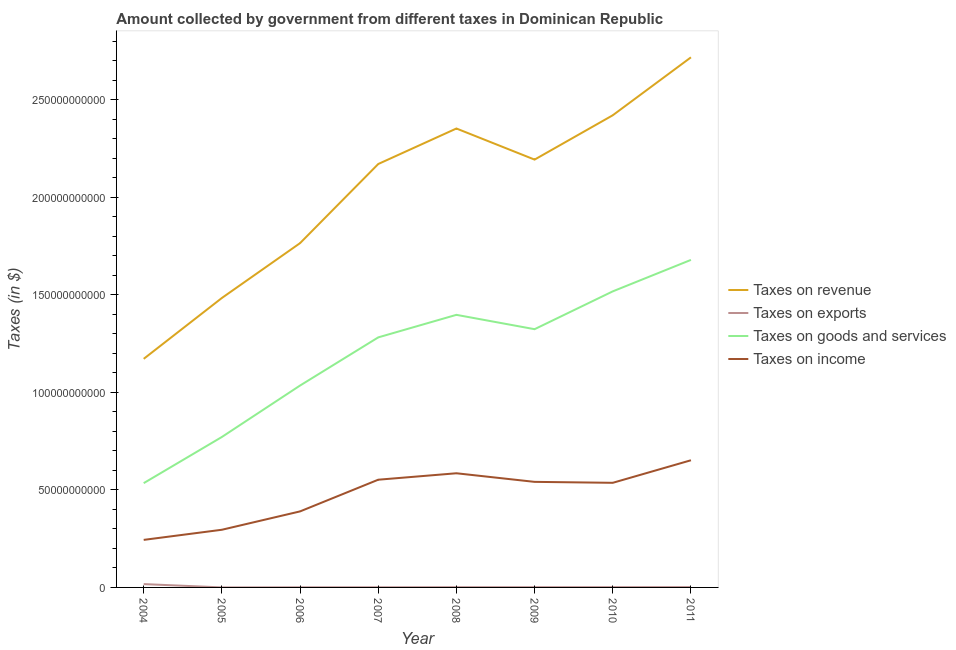How many different coloured lines are there?
Give a very brief answer. 4. Is the number of lines equal to the number of legend labels?
Offer a terse response. Yes. What is the amount collected as tax on exports in 2007?
Offer a very short reply. 8.25e+07. Across all years, what is the maximum amount collected as tax on income?
Make the answer very short. 6.52e+1. Across all years, what is the minimum amount collected as tax on revenue?
Ensure brevity in your answer.  1.17e+11. What is the total amount collected as tax on revenue in the graph?
Provide a succinct answer. 1.63e+12. What is the difference between the amount collected as tax on goods in 2007 and that in 2008?
Give a very brief answer. -1.16e+1. What is the difference between the amount collected as tax on income in 2011 and the amount collected as tax on exports in 2008?
Offer a very short reply. 6.51e+1. What is the average amount collected as tax on income per year?
Offer a very short reply. 4.75e+1. In the year 2004, what is the difference between the amount collected as tax on exports and amount collected as tax on revenue?
Provide a succinct answer. -1.15e+11. What is the ratio of the amount collected as tax on exports in 2005 to that in 2009?
Give a very brief answer. 0.1. Is the difference between the amount collected as tax on exports in 2004 and 2010 greater than the difference between the amount collected as tax on revenue in 2004 and 2010?
Offer a very short reply. Yes. What is the difference between the highest and the second highest amount collected as tax on exports?
Provide a succinct answer. 1.52e+09. What is the difference between the highest and the lowest amount collected as tax on goods?
Provide a succinct answer. 1.14e+11. Is it the case that in every year, the sum of the amount collected as tax on revenue and amount collected as tax on exports is greater than the amount collected as tax on goods?
Offer a terse response. Yes. Does the amount collected as tax on income monotonically increase over the years?
Keep it short and to the point. No. Is the amount collected as tax on income strictly greater than the amount collected as tax on goods over the years?
Your answer should be compact. No. What is the difference between two consecutive major ticks on the Y-axis?
Offer a very short reply. 5.00e+1. Are the values on the major ticks of Y-axis written in scientific E-notation?
Make the answer very short. No. How many legend labels are there?
Give a very brief answer. 4. What is the title of the graph?
Make the answer very short. Amount collected by government from different taxes in Dominican Republic. What is the label or title of the X-axis?
Provide a short and direct response. Year. What is the label or title of the Y-axis?
Offer a terse response. Taxes (in $). What is the Taxes (in $) of Taxes on revenue in 2004?
Give a very brief answer. 1.17e+11. What is the Taxes (in $) of Taxes on exports in 2004?
Give a very brief answer. 1.71e+09. What is the Taxes (in $) in Taxes on goods and services in 2004?
Provide a succinct answer. 5.35e+1. What is the Taxes (in $) of Taxes on income in 2004?
Offer a terse response. 2.44e+1. What is the Taxes (in $) of Taxes on revenue in 2005?
Offer a very short reply. 1.48e+11. What is the Taxes (in $) in Taxes on exports in 2005?
Make the answer very short. 1.36e+07. What is the Taxes (in $) of Taxes on goods and services in 2005?
Ensure brevity in your answer.  7.71e+1. What is the Taxes (in $) of Taxes on income in 2005?
Keep it short and to the point. 2.96e+1. What is the Taxes (in $) in Taxes on revenue in 2006?
Your answer should be very brief. 1.77e+11. What is the Taxes (in $) of Taxes on exports in 2006?
Offer a very short reply. 6.90e+07. What is the Taxes (in $) of Taxes on goods and services in 2006?
Keep it short and to the point. 1.04e+11. What is the Taxes (in $) in Taxes on income in 2006?
Offer a terse response. 3.90e+1. What is the Taxes (in $) in Taxes on revenue in 2007?
Ensure brevity in your answer.  2.17e+11. What is the Taxes (in $) in Taxes on exports in 2007?
Provide a succinct answer. 8.25e+07. What is the Taxes (in $) in Taxes on goods and services in 2007?
Offer a very short reply. 1.28e+11. What is the Taxes (in $) of Taxes on income in 2007?
Your answer should be very brief. 5.52e+1. What is the Taxes (in $) of Taxes on revenue in 2008?
Ensure brevity in your answer.  2.35e+11. What is the Taxes (in $) of Taxes on exports in 2008?
Provide a short and direct response. 1.28e+08. What is the Taxes (in $) of Taxes on goods and services in 2008?
Ensure brevity in your answer.  1.40e+11. What is the Taxes (in $) of Taxes on income in 2008?
Keep it short and to the point. 5.85e+1. What is the Taxes (in $) of Taxes on revenue in 2009?
Offer a terse response. 2.19e+11. What is the Taxes (in $) of Taxes on exports in 2009?
Your answer should be compact. 1.32e+08. What is the Taxes (in $) in Taxes on goods and services in 2009?
Your answer should be very brief. 1.32e+11. What is the Taxes (in $) in Taxes on income in 2009?
Make the answer very short. 5.41e+1. What is the Taxes (in $) in Taxes on revenue in 2010?
Keep it short and to the point. 2.42e+11. What is the Taxes (in $) in Taxes on exports in 2010?
Ensure brevity in your answer.  1.46e+08. What is the Taxes (in $) of Taxes on goods and services in 2010?
Your response must be concise. 1.52e+11. What is the Taxes (in $) of Taxes on income in 2010?
Your answer should be very brief. 5.36e+1. What is the Taxes (in $) of Taxes on revenue in 2011?
Keep it short and to the point. 2.72e+11. What is the Taxes (in $) in Taxes on exports in 2011?
Ensure brevity in your answer.  1.81e+08. What is the Taxes (in $) in Taxes on goods and services in 2011?
Ensure brevity in your answer.  1.68e+11. What is the Taxes (in $) of Taxes on income in 2011?
Provide a succinct answer. 6.52e+1. Across all years, what is the maximum Taxes (in $) of Taxes on revenue?
Your answer should be very brief. 2.72e+11. Across all years, what is the maximum Taxes (in $) in Taxes on exports?
Provide a succinct answer. 1.71e+09. Across all years, what is the maximum Taxes (in $) of Taxes on goods and services?
Keep it short and to the point. 1.68e+11. Across all years, what is the maximum Taxes (in $) in Taxes on income?
Provide a short and direct response. 6.52e+1. Across all years, what is the minimum Taxes (in $) of Taxes on revenue?
Provide a short and direct response. 1.17e+11. Across all years, what is the minimum Taxes (in $) of Taxes on exports?
Your answer should be compact. 1.36e+07. Across all years, what is the minimum Taxes (in $) of Taxes on goods and services?
Your answer should be compact. 5.35e+1. Across all years, what is the minimum Taxes (in $) of Taxes on income?
Your answer should be compact. 2.44e+1. What is the total Taxes (in $) of Taxes on revenue in the graph?
Provide a short and direct response. 1.63e+12. What is the total Taxes (in $) in Taxes on exports in the graph?
Give a very brief answer. 2.46e+09. What is the total Taxes (in $) of Taxes on goods and services in the graph?
Provide a succinct answer. 9.54e+11. What is the total Taxes (in $) in Taxes on income in the graph?
Make the answer very short. 3.80e+11. What is the difference between the Taxes (in $) of Taxes on revenue in 2004 and that in 2005?
Keep it short and to the point. -3.12e+1. What is the difference between the Taxes (in $) of Taxes on exports in 2004 and that in 2005?
Offer a very short reply. 1.69e+09. What is the difference between the Taxes (in $) in Taxes on goods and services in 2004 and that in 2005?
Your answer should be compact. -2.37e+1. What is the difference between the Taxes (in $) of Taxes on income in 2004 and that in 2005?
Provide a succinct answer. -5.20e+09. What is the difference between the Taxes (in $) of Taxes on revenue in 2004 and that in 2006?
Your answer should be very brief. -5.93e+1. What is the difference between the Taxes (in $) of Taxes on exports in 2004 and that in 2006?
Your answer should be compact. 1.64e+09. What is the difference between the Taxes (in $) in Taxes on goods and services in 2004 and that in 2006?
Offer a very short reply. -5.01e+1. What is the difference between the Taxes (in $) in Taxes on income in 2004 and that in 2006?
Ensure brevity in your answer.  -1.46e+1. What is the difference between the Taxes (in $) of Taxes on revenue in 2004 and that in 2007?
Offer a very short reply. -9.99e+1. What is the difference between the Taxes (in $) in Taxes on exports in 2004 and that in 2007?
Provide a succinct answer. 1.62e+09. What is the difference between the Taxes (in $) in Taxes on goods and services in 2004 and that in 2007?
Your answer should be compact. -7.47e+1. What is the difference between the Taxes (in $) of Taxes on income in 2004 and that in 2007?
Keep it short and to the point. -3.09e+1. What is the difference between the Taxes (in $) of Taxes on revenue in 2004 and that in 2008?
Your response must be concise. -1.18e+11. What is the difference between the Taxes (in $) in Taxes on exports in 2004 and that in 2008?
Provide a short and direct response. 1.58e+09. What is the difference between the Taxes (in $) of Taxes on goods and services in 2004 and that in 2008?
Your response must be concise. -8.63e+1. What is the difference between the Taxes (in $) of Taxes on income in 2004 and that in 2008?
Your answer should be very brief. -3.42e+1. What is the difference between the Taxes (in $) of Taxes on revenue in 2004 and that in 2009?
Offer a terse response. -1.02e+11. What is the difference between the Taxes (in $) of Taxes on exports in 2004 and that in 2009?
Keep it short and to the point. 1.57e+09. What is the difference between the Taxes (in $) in Taxes on goods and services in 2004 and that in 2009?
Offer a very short reply. -7.89e+1. What is the difference between the Taxes (in $) in Taxes on income in 2004 and that in 2009?
Give a very brief answer. -2.98e+1. What is the difference between the Taxes (in $) in Taxes on revenue in 2004 and that in 2010?
Make the answer very short. -1.25e+11. What is the difference between the Taxes (in $) in Taxes on exports in 2004 and that in 2010?
Keep it short and to the point. 1.56e+09. What is the difference between the Taxes (in $) of Taxes on goods and services in 2004 and that in 2010?
Provide a succinct answer. -9.83e+1. What is the difference between the Taxes (in $) in Taxes on income in 2004 and that in 2010?
Your response must be concise. -2.93e+1. What is the difference between the Taxes (in $) in Taxes on revenue in 2004 and that in 2011?
Your response must be concise. -1.55e+11. What is the difference between the Taxes (in $) in Taxes on exports in 2004 and that in 2011?
Your response must be concise. 1.52e+09. What is the difference between the Taxes (in $) in Taxes on goods and services in 2004 and that in 2011?
Offer a very short reply. -1.14e+11. What is the difference between the Taxes (in $) in Taxes on income in 2004 and that in 2011?
Provide a succinct answer. -4.08e+1. What is the difference between the Taxes (in $) of Taxes on revenue in 2005 and that in 2006?
Make the answer very short. -2.81e+1. What is the difference between the Taxes (in $) of Taxes on exports in 2005 and that in 2006?
Offer a very short reply. -5.54e+07. What is the difference between the Taxes (in $) of Taxes on goods and services in 2005 and that in 2006?
Provide a short and direct response. -2.64e+1. What is the difference between the Taxes (in $) in Taxes on income in 2005 and that in 2006?
Offer a terse response. -9.41e+09. What is the difference between the Taxes (in $) of Taxes on revenue in 2005 and that in 2007?
Your answer should be compact. -6.87e+1. What is the difference between the Taxes (in $) in Taxes on exports in 2005 and that in 2007?
Your answer should be compact. -6.89e+07. What is the difference between the Taxes (in $) in Taxes on goods and services in 2005 and that in 2007?
Offer a very short reply. -5.11e+1. What is the difference between the Taxes (in $) of Taxes on income in 2005 and that in 2007?
Keep it short and to the point. -2.57e+1. What is the difference between the Taxes (in $) of Taxes on revenue in 2005 and that in 2008?
Keep it short and to the point. -8.69e+1. What is the difference between the Taxes (in $) of Taxes on exports in 2005 and that in 2008?
Provide a succinct answer. -1.15e+08. What is the difference between the Taxes (in $) in Taxes on goods and services in 2005 and that in 2008?
Your answer should be compact. -6.26e+1. What is the difference between the Taxes (in $) in Taxes on income in 2005 and that in 2008?
Your answer should be compact. -2.90e+1. What is the difference between the Taxes (in $) of Taxes on revenue in 2005 and that in 2009?
Your response must be concise. -7.10e+1. What is the difference between the Taxes (in $) of Taxes on exports in 2005 and that in 2009?
Offer a very short reply. -1.18e+08. What is the difference between the Taxes (in $) in Taxes on goods and services in 2005 and that in 2009?
Provide a short and direct response. -5.53e+1. What is the difference between the Taxes (in $) in Taxes on income in 2005 and that in 2009?
Your answer should be compact. -2.46e+1. What is the difference between the Taxes (in $) in Taxes on revenue in 2005 and that in 2010?
Keep it short and to the point. -9.37e+1. What is the difference between the Taxes (in $) in Taxes on exports in 2005 and that in 2010?
Your answer should be very brief. -1.33e+08. What is the difference between the Taxes (in $) of Taxes on goods and services in 2005 and that in 2010?
Ensure brevity in your answer.  -7.47e+1. What is the difference between the Taxes (in $) of Taxes on income in 2005 and that in 2010?
Your response must be concise. -2.41e+1. What is the difference between the Taxes (in $) of Taxes on revenue in 2005 and that in 2011?
Your response must be concise. -1.23e+11. What is the difference between the Taxes (in $) of Taxes on exports in 2005 and that in 2011?
Provide a short and direct response. -1.68e+08. What is the difference between the Taxes (in $) in Taxes on goods and services in 2005 and that in 2011?
Ensure brevity in your answer.  -9.08e+1. What is the difference between the Taxes (in $) of Taxes on income in 2005 and that in 2011?
Provide a succinct answer. -3.56e+1. What is the difference between the Taxes (in $) of Taxes on revenue in 2006 and that in 2007?
Provide a succinct answer. -4.06e+1. What is the difference between the Taxes (in $) of Taxes on exports in 2006 and that in 2007?
Offer a very short reply. -1.35e+07. What is the difference between the Taxes (in $) of Taxes on goods and services in 2006 and that in 2007?
Give a very brief answer. -2.47e+1. What is the difference between the Taxes (in $) of Taxes on income in 2006 and that in 2007?
Give a very brief answer. -1.63e+1. What is the difference between the Taxes (in $) in Taxes on revenue in 2006 and that in 2008?
Offer a very short reply. -5.88e+1. What is the difference between the Taxes (in $) of Taxes on exports in 2006 and that in 2008?
Your response must be concise. -5.92e+07. What is the difference between the Taxes (in $) of Taxes on goods and services in 2006 and that in 2008?
Give a very brief answer. -3.62e+1. What is the difference between the Taxes (in $) in Taxes on income in 2006 and that in 2008?
Your answer should be very brief. -1.96e+1. What is the difference between the Taxes (in $) of Taxes on revenue in 2006 and that in 2009?
Offer a terse response. -4.28e+1. What is the difference between the Taxes (in $) of Taxes on exports in 2006 and that in 2009?
Give a very brief answer. -6.27e+07. What is the difference between the Taxes (in $) of Taxes on goods and services in 2006 and that in 2009?
Provide a short and direct response. -2.89e+1. What is the difference between the Taxes (in $) of Taxes on income in 2006 and that in 2009?
Ensure brevity in your answer.  -1.51e+1. What is the difference between the Taxes (in $) in Taxes on revenue in 2006 and that in 2010?
Give a very brief answer. -6.56e+1. What is the difference between the Taxes (in $) of Taxes on exports in 2006 and that in 2010?
Your answer should be compact. -7.73e+07. What is the difference between the Taxes (in $) in Taxes on goods and services in 2006 and that in 2010?
Give a very brief answer. -4.83e+1. What is the difference between the Taxes (in $) of Taxes on income in 2006 and that in 2010?
Provide a succinct answer. -1.47e+1. What is the difference between the Taxes (in $) of Taxes on revenue in 2006 and that in 2011?
Offer a terse response. -9.53e+1. What is the difference between the Taxes (in $) in Taxes on exports in 2006 and that in 2011?
Make the answer very short. -1.12e+08. What is the difference between the Taxes (in $) of Taxes on goods and services in 2006 and that in 2011?
Keep it short and to the point. -6.44e+1. What is the difference between the Taxes (in $) in Taxes on income in 2006 and that in 2011?
Your answer should be compact. -2.62e+1. What is the difference between the Taxes (in $) of Taxes on revenue in 2007 and that in 2008?
Your response must be concise. -1.82e+1. What is the difference between the Taxes (in $) of Taxes on exports in 2007 and that in 2008?
Your answer should be compact. -4.56e+07. What is the difference between the Taxes (in $) in Taxes on goods and services in 2007 and that in 2008?
Make the answer very short. -1.16e+1. What is the difference between the Taxes (in $) in Taxes on income in 2007 and that in 2008?
Your response must be concise. -3.30e+09. What is the difference between the Taxes (in $) of Taxes on revenue in 2007 and that in 2009?
Your response must be concise. -2.26e+09. What is the difference between the Taxes (in $) of Taxes on exports in 2007 and that in 2009?
Provide a short and direct response. -4.92e+07. What is the difference between the Taxes (in $) of Taxes on goods and services in 2007 and that in 2009?
Provide a short and direct response. -4.20e+09. What is the difference between the Taxes (in $) in Taxes on income in 2007 and that in 2009?
Provide a short and direct response. 1.10e+09. What is the difference between the Taxes (in $) of Taxes on revenue in 2007 and that in 2010?
Your answer should be very brief. -2.50e+1. What is the difference between the Taxes (in $) of Taxes on exports in 2007 and that in 2010?
Your response must be concise. -6.38e+07. What is the difference between the Taxes (in $) of Taxes on goods and services in 2007 and that in 2010?
Offer a terse response. -2.36e+1. What is the difference between the Taxes (in $) of Taxes on income in 2007 and that in 2010?
Give a very brief answer. 1.59e+09. What is the difference between the Taxes (in $) of Taxes on revenue in 2007 and that in 2011?
Make the answer very short. -5.47e+1. What is the difference between the Taxes (in $) in Taxes on exports in 2007 and that in 2011?
Your answer should be very brief. -9.87e+07. What is the difference between the Taxes (in $) of Taxes on goods and services in 2007 and that in 2011?
Provide a succinct answer. -3.97e+1. What is the difference between the Taxes (in $) in Taxes on income in 2007 and that in 2011?
Keep it short and to the point. -9.97e+09. What is the difference between the Taxes (in $) in Taxes on revenue in 2008 and that in 2009?
Make the answer very short. 1.59e+1. What is the difference between the Taxes (in $) of Taxes on exports in 2008 and that in 2009?
Ensure brevity in your answer.  -3.52e+06. What is the difference between the Taxes (in $) of Taxes on goods and services in 2008 and that in 2009?
Keep it short and to the point. 7.36e+09. What is the difference between the Taxes (in $) in Taxes on income in 2008 and that in 2009?
Offer a very short reply. 4.41e+09. What is the difference between the Taxes (in $) of Taxes on revenue in 2008 and that in 2010?
Your answer should be very brief. -6.79e+09. What is the difference between the Taxes (in $) in Taxes on exports in 2008 and that in 2010?
Offer a terse response. -1.82e+07. What is the difference between the Taxes (in $) of Taxes on goods and services in 2008 and that in 2010?
Your response must be concise. -1.20e+1. What is the difference between the Taxes (in $) of Taxes on income in 2008 and that in 2010?
Your response must be concise. 4.89e+09. What is the difference between the Taxes (in $) of Taxes on revenue in 2008 and that in 2011?
Your answer should be very brief. -3.65e+1. What is the difference between the Taxes (in $) in Taxes on exports in 2008 and that in 2011?
Make the answer very short. -5.31e+07. What is the difference between the Taxes (in $) of Taxes on goods and services in 2008 and that in 2011?
Offer a very short reply. -2.82e+1. What is the difference between the Taxes (in $) in Taxes on income in 2008 and that in 2011?
Provide a succinct answer. -6.67e+09. What is the difference between the Taxes (in $) in Taxes on revenue in 2009 and that in 2010?
Your response must be concise. -2.27e+1. What is the difference between the Taxes (in $) in Taxes on exports in 2009 and that in 2010?
Keep it short and to the point. -1.46e+07. What is the difference between the Taxes (in $) of Taxes on goods and services in 2009 and that in 2010?
Give a very brief answer. -1.94e+1. What is the difference between the Taxes (in $) of Taxes on income in 2009 and that in 2010?
Keep it short and to the point. 4.84e+08. What is the difference between the Taxes (in $) of Taxes on revenue in 2009 and that in 2011?
Your answer should be very brief. -5.24e+1. What is the difference between the Taxes (in $) in Taxes on exports in 2009 and that in 2011?
Give a very brief answer. -4.95e+07. What is the difference between the Taxes (in $) of Taxes on goods and services in 2009 and that in 2011?
Your response must be concise. -3.55e+1. What is the difference between the Taxes (in $) in Taxes on income in 2009 and that in 2011?
Give a very brief answer. -1.11e+1. What is the difference between the Taxes (in $) of Taxes on revenue in 2010 and that in 2011?
Keep it short and to the point. -2.97e+1. What is the difference between the Taxes (in $) in Taxes on exports in 2010 and that in 2011?
Keep it short and to the point. -3.49e+07. What is the difference between the Taxes (in $) of Taxes on goods and services in 2010 and that in 2011?
Your answer should be very brief. -1.61e+1. What is the difference between the Taxes (in $) of Taxes on income in 2010 and that in 2011?
Make the answer very short. -1.16e+1. What is the difference between the Taxes (in $) of Taxes on revenue in 2004 and the Taxes (in $) of Taxes on exports in 2005?
Your answer should be very brief. 1.17e+11. What is the difference between the Taxes (in $) of Taxes on revenue in 2004 and the Taxes (in $) of Taxes on goods and services in 2005?
Keep it short and to the point. 4.01e+1. What is the difference between the Taxes (in $) in Taxes on revenue in 2004 and the Taxes (in $) in Taxes on income in 2005?
Keep it short and to the point. 8.76e+1. What is the difference between the Taxes (in $) of Taxes on exports in 2004 and the Taxes (in $) of Taxes on goods and services in 2005?
Your answer should be very brief. -7.54e+1. What is the difference between the Taxes (in $) of Taxes on exports in 2004 and the Taxes (in $) of Taxes on income in 2005?
Your answer should be very brief. -2.79e+1. What is the difference between the Taxes (in $) of Taxes on goods and services in 2004 and the Taxes (in $) of Taxes on income in 2005?
Your response must be concise. 2.39e+1. What is the difference between the Taxes (in $) in Taxes on revenue in 2004 and the Taxes (in $) in Taxes on exports in 2006?
Your answer should be compact. 1.17e+11. What is the difference between the Taxes (in $) in Taxes on revenue in 2004 and the Taxes (in $) in Taxes on goods and services in 2006?
Your response must be concise. 1.37e+1. What is the difference between the Taxes (in $) of Taxes on revenue in 2004 and the Taxes (in $) of Taxes on income in 2006?
Provide a succinct answer. 7.82e+1. What is the difference between the Taxes (in $) in Taxes on exports in 2004 and the Taxes (in $) in Taxes on goods and services in 2006?
Provide a short and direct response. -1.02e+11. What is the difference between the Taxes (in $) in Taxes on exports in 2004 and the Taxes (in $) in Taxes on income in 2006?
Your response must be concise. -3.73e+1. What is the difference between the Taxes (in $) of Taxes on goods and services in 2004 and the Taxes (in $) of Taxes on income in 2006?
Keep it short and to the point. 1.45e+1. What is the difference between the Taxes (in $) of Taxes on revenue in 2004 and the Taxes (in $) of Taxes on exports in 2007?
Your answer should be compact. 1.17e+11. What is the difference between the Taxes (in $) in Taxes on revenue in 2004 and the Taxes (in $) in Taxes on goods and services in 2007?
Ensure brevity in your answer.  -1.10e+1. What is the difference between the Taxes (in $) of Taxes on revenue in 2004 and the Taxes (in $) of Taxes on income in 2007?
Keep it short and to the point. 6.20e+1. What is the difference between the Taxes (in $) of Taxes on exports in 2004 and the Taxes (in $) of Taxes on goods and services in 2007?
Your response must be concise. -1.27e+11. What is the difference between the Taxes (in $) of Taxes on exports in 2004 and the Taxes (in $) of Taxes on income in 2007?
Make the answer very short. -5.35e+1. What is the difference between the Taxes (in $) in Taxes on goods and services in 2004 and the Taxes (in $) in Taxes on income in 2007?
Offer a very short reply. -1.76e+09. What is the difference between the Taxes (in $) in Taxes on revenue in 2004 and the Taxes (in $) in Taxes on exports in 2008?
Provide a short and direct response. 1.17e+11. What is the difference between the Taxes (in $) in Taxes on revenue in 2004 and the Taxes (in $) in Taxes on goods and services in 2008?
Ensure brevity in your answer.  -2.26e+1. What is the difference between the Taxes (in $) of Taxes on revenue in 2004 and the Taxes (in $) of Taxes on income in 2008?
Keep it short and to the point. 5.87e+1. What is the difference between the Taxes (in $) in Taxes on exports in 2004 and the Taxes (in $) in Taxes on goods and services in 2008?
Your answer should be very brief. -1.38e+11. What is the difference between the Taxes (in $) of Taxes on exports in 2004 and the Taxes (in $) of Taxes on income in 2008?
Your response must be concise. -5.68e+1. What is the difference between the Taxes (in $) in Taxes on goods and services in 2004 and the Taxes (in $) in Taxes on income in 2008?
Provide a succinct answer. -5.07e+09. What is the difference between the Taxes (in $) of Taxes on revenue in 2004 and the Taxes (in $) of Taxes on exports in 2009?
Keep it short and to the point. 1.17e+11. What is the difference between the Taxes (in $) of Taxes on revenue in 2004 and the Taxes (in $) of Taxes on goods and services in 2009?
Offer a very short reply. -1.52e+1. What is the difference between the Taxes (in $) in Taxes on revenue in 2004 and the Taxes (in $) in Taxes on income in 2009?
Ensure brevity in your answer.  6.31e+1. What is the difference between the Taxes (in $) in Taxes on exports in 2004 and the Taxes (in $) in Taxes on goods and services in 2009?
Provide a succinct answer. -1.31e+11. What is the difference between the Taxes (in $) in Taxes on exports in 2004 and the Taxes (in $) in Taxes on income in 2009?
Your answer should be compact. -5.24e+1. What is the difference between the Taxes (in $) in Taxes on goods and services in 2004 and the Taxes (in $) in Taxes on income in 2009?
Offer a terse response. -6.59e+08. What is the difference between the Taxes (in $) in Taxes on revenue in 2004 and the Taxes (in $) in Taxes on exports in 2010?
Provide a succinct answer. 1.17e+11. What is the difference between the Taxes (in $) in Taxes on revenue in 2004 and the Taxes (in $) in Taxes on goods and services in 2010?
Make the answer very short. -3.46e+1. What is the difference between the Taxes (in $) in Taxes on revenue in 2004 and the Taxes (in $) in Taxes on income in 2010?
Give a very brief answer. 6.36e+1. What is the difference between the Taxes (in $) in Taxes on exports in 2004 and the Taxes (in $) in Taxes on goods and services in 2010?
Make the answer very short. -1.50e+11. What is the difference between the Taxes (in $) of Taxes on exports in 2004 and the Taxes (in $) of Taxes on income in 2010?
Provide a succinct answer. -5.19e+1. What is the difference between the Taxes (in $) in Taxes on goods and services in 2004 and the Taxes (in $) in Taxes on income in 2010?
Ensure brevity in your answer.  -1.75e+08. What is the difference between the Taxes (in $) in Taxes on revenue in 2004 and the Taxes (in $) in Taxes on exports in 2011?
Offer a terse response. 1.17e+11. What is the difference between the Taxes (in $) of Taxes on revenue in 2004 and the Taxes (in $) of Taxes on goods and services in 2011?
Keep it short and to the point. -5.07e+1. What is the difference between the Taxes (in $) in Taxes on revenue in 2004 and the Taxes (in $) in Taxes on income in 2011?
Make the answer very short. 5.20e+1. What is the difference between the Taxes (in $) in Taxes on exports in 2004 and the Taxes (in $) in Taxes on goods and services in 2011?
Provide a short and direct response. -1.66e+11. What is the difference between the Taxes (in $) of Taxes on exports in 2004 and the Taxes (in $) of Taxes on income in 2011?
Keep it short and to the point. -6.35e+1. What is the difference between the Taxes (in $) in Taxes on goods and services in 2004 and the Taxes (in $) in Taxes on income in 2011?
Offer a very short reply. -1.17e+1. What is the difference between the Taxes (in $) of Taxes on revenue in 2005 and the Taxes (in $) of Taxes on exports in 2006?
Give a very brief answer. 1.48e+11. What is the difference between the Taxes (in $) of Taxes on revenue in 2005 and the Taxes (in $) of Taxes on goods and services in 2006?
Offer a very short reply. 4.49e+1. What is the difference between the Taxes (in $) in Taxes on revenue in 2005 and the Taxes (in $) in Taxes on income in 2006?
Provide a succinct answer. 1.09e+11. What is the difference between the Taxes (in $) in Taxes on exports in 2005 and the Taxes (in $) in Taxes on goods and services in 2006?
Keep it short and to the point. -1.04e+11. What is the difference between the Taxes (in $) of Taxes on exports in 2005 and the Taxes (in $) of Taxes on income in 2006?
Your answer should be compact. -3.90e+1. What is the difference between the Taxes (in $) of Taxes on goods and services in 2005 and the Taxes (in $) of Taxes on income in 2006?
Your answer should be very brief. 3.82e+1. What is the difference between the Taxes (in $) in Taxes on revenue in 2005 and the Taxes (in $) in Taxes on exports in 2007?
Offer a terse response. 1.48e+11. What is the difference between the Taxes (in $) in Taxes on revenue in 2005 and the Taxes (in $) in Taxes on goods and services in 2007?
Keep it short and to the point. 2.02e+1. What is the difference between the Taxes (in $) of Taxes on revenue in 2005 and the Taxes (in $) of Taxes on income in 2007?
Make the answer very short. 9.32e+1. What is the difference between the Taxes (in $) in Taxes on exports in 2005 and the Taxes (in $) in Taxes on goods and services in 2007?
Make the answer very short. -1.28e+11. What is the difference between the Taxes (in $) of Taxes on exports in 2005 and the Taxes (in $) of Taxes on income in 2007?
Make the answer very short. -5.52e+1. What is the difference between the Taxes (in $) of Taxes on goods and services in 2005 and the Taxes (in $) of Taxes on income in 2007?
Offer a terse response. 2.19e+1. What is the difference between the Taxes (in $) in Taxes on revenue in 2005 and the Taxes (in $) in Taxes on exports in 2008?
Give a very brief answer. 1.48e+11. What is the difference between the Taxes (in $) in Taxes on revenue in 2005 and the Taxes (in $) in Taxes on goods and services in 2008?
Offer a terse response. 8.65e+09. What is the difference between the Taxes (in $) of Taxes on revenue in 2005 and the Taxes (in $) of Taxes on income in 2008?
Ensure brevity in your answer.  8.99e+1. What is the difference between the Taxes (in $) in Taxes on exports in 2005 and the Taxes (in $) in Taxes on goods and services in 2008?
Your response must be concise. -1.40e+11. What is the difference between the Taxes (in $) of Taxes on exports in 2005 and the Taxes (in $) of Taxes on income in 2008?
Your answer should be compact. -5.85e+1. What is the difference between the Taxes (in $) of Taxes on goods and services in 2005 and the Taxes (in $) of Taxes on income in 2008?
Make the answer very short. 1.86e+1. What is the difference between the Taxes (in $) of Taxes on revenue in 2005 and the Taxes (in $) of Taxes on exports in 2009?
Your answer should be very brief. 1.48e+11. What is the difference between the Taxes (in $) in Taxes on revenue in 2005 and the Taxes (in $) in Taxes on goods and services in 2009?
Keep it short and to the point. 1.60e+1. What is the difference between the Taxes (in $) of Taxes on revenue in 2005 and the Taxes (in $) of Taxes on income in 2009?
Your answer should be compact. 9.43e+1. What is the difference between the Taxes (in $) in Taxes on exports in 2005 and the Taxes (in $) in Taxes on goods and services in 2009?
Your answer should be very brief. -1.32e+11. What is the difference between the Taxes (in $) in Taxes on exports in 2005 and the Taxes (in $) in Taxes on income in 2009?
Your answer should be compact. -5.41e+1. What is the difference between the Taxes (in $) of Taxes on goods and services in 2005 and the Taxes (in $) of Taxes on income in 2009?
Ensure brevity in your answer.  2.30e+1. What is the difference between the Taxes (in $) of Taxes on revenue in 2005 and the Taxes (in $) of Taxes on exports in 2010?
Make the answer very short. 1.48e+11. What is the difference between the Taxes (in $) of Taxes on revenue in 2005 and the Taxes (in $) of Taxes on goods and services in 2010?
Your answer should be very brief. -3.39e+09. What is the difference between the Taxes (in $) in Taxes on revenue in 2005 and the Taxes (in $) in Taxes on income in 2010?
Your answer should be compact. 9.48e+1. What is the difference between the Taxes (in $) in Taxes on exports in 2005 and the Taxes (in $) in Taxes on goods and services in 2010?
Your answer should be compact. -1.52e+11. What is the difference between the Taxes (in $) in Taxes on exports in 2005 and the Taxes (in $) in Taxes on income in 2010?
Your answer should be compact. -5.36e+1. What is the difference between the Taxes (in $) of Taxes on goods and services in 2005 and the Taxes (in $) of Taxes on income in 2010?
Your answer should be compact. 2.35e+1. What is the difference between the Taxes (in $) of Taxes on revenue in 2005 and the Taxes (in $) of Taxes on exports in 2011?
Make the answer very short. 1.48e+11. What is the difference between the Taxes (in $) of Taxes on revenue in 2005 and the Taxes (in $) of Taxes on goods and services in 2011?
Provide a succinct answer. -1.95e+1. What is the difference between the Taxes (in $) in Taxes on revenue in 2005 and the Taxes (in $) in Taxes on income in 2011?
Make the answer very short. 8.32e+1. What is the difference between the Taxes (in $) in Taxes on exports in 2005 and the Taxes (in $) in Taxes on goods and services in 2011?
Give a very brief answer. -1.68e+11. What is the difference between the Taxes (in $) of Taxes on exports in 2005 and the Taxes (in $) of Taxes on income in 2011?
Offer a very short reply. -6.52e+1. What is the difference between the Taxes (in $) in Taxes on goods and services in 2005 and the Taxes (in $) in Taxes on income in 2011?
Your answer should be very brief. 1.19e+1. What is the difference between the Taxes (in $) in Taxes on revenue in 2006 and the Taxes (in $) in Taxes on exports in 2007?
Make the answer very short. 1.76e+11. What is the difference between the Taxes (in $) in Taxes on revenue in 2006 and the Taxes (in $) in Taxes on goods and services in 2007?
Give a very brief answer. 4.83e+1. What is the difference between the Taxes (in $) in Taxes on revenue in 2006 and the Taxes (in $) in Taxes on income in 2007?
Keep it short and to the point. 1.21e+11. What is the difference between the Taxes (in $) of Taxes on exports in 2006 and the Taxes (in $) of Taxes on goods and services in 2007?
Your response must be concise. -1.28e+11. What is the difference between the Taxes (in $) in Taxes on exports in 2006 and the Taxes (in $) in Taxes on income in 2007?
Provide a short and direct response. -5.52e+1. What is the difference between the Taxes (in $) in Taxes on goods and services in 2006 and the Taxes (in $) in Taxes on income in 2007?
Keep it short and to the point. 4.83e+1. What is the difference between the Taxes (in $) of Taxes on revenue in 2006 and the Taxes (in $) of Taxes on exports in 2008?
Give a very brief answer. 1.76e+11. What is the difference between the Taxes (in $) in Taxes on revenue in 2006 and the Taxes (in $) in Taxes on goods and services in 2008?
Keep it short and to the point. 3.68e+1. What is the difference between the Taxes (in $) in Taxes on revenue in 2006 and the Taxes (in $) in Taxes on income in 2008?
Ensure brevity in your answer.  1.18e+11. What is the difference between the Taxes (in $) of Taxes on exports in 2006 and the Taxes (in $) of Taxes on goods and services in 2008?
Offer a very short reply. -1.40e+11. What is the difference between the Taxes (in $) in Taxes on exports in 2006 and the Taxes (in $) in Taxes on income in 2008?
Give a very brief answer. -5.85e+1. What is the difference between the Taxes (in $) in Taxes on goods and services in 2006 and the Taxes (in $) in Taxes on income in 2008?
Offer a very short reply. 4.50e+1. What is the difference between the Taxes (in $) of Taxes on revenue in 2006 and the Taxes (in $) of Taxes on exports in 2009?
Offer a very short reply. 1.76e+11. What is the difference between the Taxes (in $) of Taxes on revenue in 2006 and the Taxes (in $) of Taxes on goods and services in 2009?
Keep it short and to the point. 4.41e+1. What is the difference between the Taxes (in $) of Taxes on revenue in 2006 and the Taxes (in $) of Taxes on income in 2009?
Provide a succinct answer. 1.22e+11. What is the difference between the Taxes (in $) in Taxes on exports in 2006 and the Taxes (in $) in Taxes on goods and services in 2009?
Provide a short and direct response. -1.32e+11. What is the difference between the Taxes (in $) in Taxes on exports in 2006 and the Taxes (in $) in Taxes on income in 2009?
Your response must be concise. -5.41e+1. What is the difference between the Taxes (in $) of Taxes on goods and services in 2006 and the Taxes (in $) of Taxes on income in 2009?
Give a very brief answer. 4.94e+1. What is the difference between the Taxes (in $) of Taxes on revenue in 2006 and the Taxes (in $) of Taxes on exports in 2010?
Keep it short and to the point. 1.76e+11. What is the difference between the Taxes (in $) in Taxes on revenue in 2006 and the Taxes (in $) in Taxes on goods and services in 2010?
Provide a short and direct response. 2.47e+1. What is the difference between the Taxes (in $) of Taxes on revenue in 2006 and the Taxes (in $) of Taxes on income in 2010?
Give a very brief answer. 1.23e+11. What is the difference between the Taxes (in $) of Taxes on exports in 2006 and the Taxes (in $) of Taxes on goods and services in 2010?
Offer a very short reply. -1.52e+11. What is the difference between the Taxes (in $) in Taxes on exports in 2006 and the Taxes (in $) in Taxes on income in 2010?
Ensure brevity in your answer.  -5.36e+1. What is the difference between the Taxes (in $) of Taxes on goods and services in 2006 and the Taxes (in $) of Taxes on income in 2010?
Offer a very short reply. 4.99e+1. What is the difference between the Taxes (in $) in Taxes on revenue in 2006 and the Taxes (in $) in Taxes on exports in 2011?
Ensure brevity in your answer.  1.76e+11. What is the difference between the Taxes (in $) of Taxes on revenue in 2006 and the Taxes (in $) of Taxes on goods and services in 2011?
Your answer should be compact. 8.59e+09. What is the difference between the Taxes (in $) in Taxes on revenue in 2006 and the Taxes (in $) in Taxes on income in 2011?
Your response must be concise. 1.11e+11. What is the difference between the Taxes (in $) of Taxes on exports in 2006 and the Taxes (in $) of Taxes on goods and services in 2011?
Offer a very short reply. -1.68e+11. What is the difference between the Taxes (in $) of Taxes on exports in 2006 and the Taxes (in $) of Taxes on income in 2011?
Offer a terse response. -6.51e+1. What is the difference between the Taxes (in $) of Taxes on goods and services in 2006 and the Taxes (in $) of Taxes on income in 2011?
Give a very brief answer. 3.83e+1. What is the difference between the Taxes (in $) of Taxes on revenue in 2007 and the Taxes (in $) of Taxes on exports in 2008?
Your response must be concise. 2.17e+11. What is the difference between the Taxes (in $) of Taxes on revenue in 2007 and the Taxes (in $) of Taxes on goods and services in 2008?
Your answer should be very brief. 7.73e+1. What is the difference between the Taxes (in $) of Taxes on revenue in 2007 and the Taxes (in $) of Taxes on income in 2008?
Keep it short and to the point. 1.59e+11. What is the difference between the Taxes (in $) in Taxes on exports in 2007 and the Taxes (in $) in Taxes on goods and services in 2008?
Offer a very short reply. -1.40e+11. What is the difference between the Taxes (in $) of Taxes on exports in 2007 and the Taxes (in $) of Taxes on income in 2008?
Your response must be concise. -5.85e+1. What is the difference between the Taxes (in $) of Taxes on goods and services in 2007 and the Taxes (in $) of Taxes on income in 2008?
Ensure brevity in your answer.  6.97e+1. What is the difference between the Taxes (in $) of Taxes on revenue in 2007 and the Taxes (in $) of Taxes on exports in 2009?
Provide a short and direct response. 2.17e+11. What is the difference between the Taxes (in $) of Taxes on revenue in 2007 and the Taxes (in $) of Taxes on goods and services in 2009?
Offer a terse response. 8.47e+1. What is the difference between the Taxes (in $) of Taxes on revenue in 2007 and the Taxes (in $) of Taxes on income in 2009?
Give a very brief answer. 1.63e+11. What is the difference between the Taxes (in $) in Taxes on exports in 2007 and the Taxes (in $) in Taxes on goods and services in 2009?
Keep it short and to the point. -1.32e+11. What is the difference between the Taxes (in $) of Taxes on exports in 2007 and the Taxes (in $) of Taxes on income in 2009?
Your answer should be very brief. -5.40e+1. What is the difference between the Taxes (in $) in Taxes on goods and services in 2007 and the Taxes (in $) in Taxes on income in 2009?
Make the answer very short. 7.41e+1. What is the difference between the Taxes (in $) in Taxes on revenue in 2007 and the Taxes (in $) in Taxes on exports in 2010?
Offer a terse response. 2.17e+11. What is the difference between the Taxes (in $) in Taxes on revenue in 2007 and the Taxes (in $) in Taxes on goods and services in 2010?
Your response must be concise. 6.53e+1. What is the difference between the Taxes (in $) of Taxes on revenue in 2007 and the Taxes (in $) of Taxes on income in 2010?
Your answer should be very brief. 1.63e+11. What is the difference between the Taxes (in $) in Taxes on exports in 2007 and the Taxes (in $) in Taxes on goods and services in 2010?
Keep it short and to the point. -1.52e+11. What is the difference between the Taxes (in $) of Taxes on exports in 2007 and the Taxes (in $) of Taxes on income in 2010?
Your response must be concise. -5.36e+1. What is the difference between the Taxes (in $) in Taxes on goods and services in 2007 and the Taxes (in $) in Taxes on income in 2010?
Make the answer very short. 7.46e+1. What is the difference between the Taxes (in $) in Taxes on revenue in 2007 and the Taxes (in $) in Taxes on exports in 2011?
Offer a terse response. 2.17e+11. What is the difference between the Taxes (in $) of Taxes on revenue in 2007 and the Taxes (in $) of Taxes on goods and services in 2011?
Provide a short and direct response. 4.92e+1. What is the difference between the Taxes (in $) in Taxes on revenue in 2007 and the Taxes (in $) in Taxes on income in 2011?
Offer a terse response. 1.52e+11. What is the difference between the Taxes (in $) of Taxes on exports in 2007 and the Taxes (in $) of Taxes on goods and services in 2011?
Ensure brevity in your answer.  -1.68e+11. What is the difference between the Taxes (in $) of Taxes on exports in 2007 and the Taxes (in $) of Taxes on income in 2011?
Make the answer very short. -6.51e+1. What is the difference between the Taxes (in $) in Taxes on goods and services in 2007 and the Taxes (in $) in Taxes on income in 2011?
Give a very brief answer. 6.30e+1. What is the difference between the Taxes (in $) of Taxes on revenue in 2008 and the Taxes (in $) of Taxes on exports in 2009?
Give a very brief answer. 2.35e+11. What is the difference between the Taxes (in $) of Taxes on revenue in 2008 and the Taxes (in $) of Taxes on goods and services in 2009?
Provide a succinct answer. 1.03e+11. What is the difference between the Taxes (in $) of Taxes on revenue in 2008 and the Taxes (in $) of Taxes on income in 2009?
Offer a very short reply. 1.81e+11. What is the difference between the Taxes (in $) of Taxes on exports in 2008 and the Taxes (in $) of Taxes on goods and services in 2009?
Your answer should be compact. -1.32e+11. What is the difference between the Taxes (in $) in Taxes on exports in 2008 and the Taxes (in $) in Taxes on income in 2009?
Your response must be concise. -5.40e+1. What is the difference between the Taxes (in $) in Taxes on goods and services in 2008 and the Taxes (in $) in Taxes on income in 2009?
Keep it short and to the point. 8.56e+1. What is the difference between the Taxes (in $) in Taxes on revenue in 2008 and the Taxes (in $) in Taxes on exports in 2010?
Offer a very short reply. 2.35e+11. What is the difference between the Taxes (in $) of Taxes on revenue in 2008 and the Taxes (in $) of Taxes on goods and services in 2010?
Offer a very short reply. 8.35e+1. What is the difference between the Taxes (in $) of Taxes on revenue in 2008 and the Taxes (in $) of Taxes on income in 2010?
Your answer should be very brief. 1.82e+11. What is the difference between the Taxes (in $) of Taxes on exports in 2008 and the Taxes (in $) of Taxes on goods and services in 2010?
Ensure brevity in your answer.  -1.52e+11. What is the difference between the Taxes (in $) of Taxes on exports in 2008 and the Taxes (in $) of Taxes on income in 2010?
Provide a succinct answer. -5.35e+1. What is the difference between the Taxes (in $) in Taxes on goods and services in 2008 and the Taxes (in $) in Taxes on income in 2010?
Make the answer very short. 8.61e+1. What is the difference between the Taxes (in $) in Taxes on revenue in 2008 and the Taxes (in $) in Taxes on exports in 2011?
Your answer should be very brief. 2.35e+11. What is the difference between the Taxes (in $) of Taxes on revenue in 2008 and the Taxes (in $) of Taxes on goods and services in 2011?
Your response must be concise. 6.74e+1. What is the difference between the Taxes (in $) in Taxes on revenue in 2008 and the Taxes (in $) in Taxes on income in 2011?
Offer a terse response. 1.70e+11. What is the difference between the Taxes (in $) in Taxes on exports in 2008 and the Taxes (in $) in Taxes on goods and services in 2011?
Offer a terse response. -1.68e+11. What is the difference between the Taxes (in $) of Taxes on exports in 2008 and the Taxes (in $) of Taxes on income in 2011?
Your answer should be very brief. -6.51e+1. What is the difference between the Taxes (in $) in Taxes on goods and services in 2008 and the Taxes (in $) in Taxes on income in 2011?
Ensure brevity in your answer.  7.46e+1. What is the difference between the Taxes (in $) of Taxes on revenue in 2009 and the Taxes (in $) of Taxes on exports in 2010?
Ensure brevity in your answer.  2.19e+11. What is the difference between the Taxes (in $) of Taxes on revenue in 2009 and the Taxes (in $) of Taxes on goods and services in 2010?
Give a very brief answer. 6.76e+1. What is the difference between the Taxes (in $) of Taxes on revenue in 2009 and the Taxes (in $) of Taxes on income in 2010?
Provide a short and direct response. 1.66e+11. What is the difference between the Taxes (in $) of Taxes on exports in 2009 and the Taxes (in $) of Taxes on goods and services in 2010?
Ensure brevity in your answer.  -1.52e+11. What is the difference between the Taxes (in $) in Taxes on exports in 2009 and the Taxes (in $) in Taxes on income in 2010?
Make the answer very short. -5.35e+1. What is the difference between the Taxes (in $) in Taxes on goods and services in 2009 and the Taxes (in $) in Taxes on income in 2010?
Give a very brief answer. 7.88e+1. What is the difference between the Taxes (in $) in Taxes on revenue in 2009 and the Taxes (in $) in Taxes on exports in 2011?
Your answer should be very brief. 2.19e+11. What is the difference between the Taxes (in $) in Taxes on revenue in 2009 and the Taxes (in $) in Taxes on goods and services in 2011?
Provide a succinct answer. 5.14e+1. What is the difference between the Taxes (in $) of Taxes on revenue in 2009 and the Taxes (in $) of Taxes on income in 2011?
Offer a terse response. 1.54e+11. What is the difference between the Taxes (in $) of Taxes on exports in 2009 and the Taxes (in $) of Taxes on goods and services in 2011?
Ensure brevity in your answer.  -1.68e+11. What is the difference between the Taxes (in $) in Taxes on exports in 2009 and the Taxes (in $) in Taxes on income in 2011?
Your answer should be compact. -6.51e+1. What is the difference between the Taxes (in $) in Taxes on goods and services in 2009 and the Taxes (in $) in Taxes on income in 2011?
Keep it short and to the point. 6.72e+1. What is the difference between the Taxes (in $) in Taxes on revenue in 2010 and the Taxes (in $) in Taxes on exports in 2011?
Your answer should be very brief. 2.42e+11. What is the difference between the Taxes (in $) of Taxes on revenue in 2010 and the Taxes (in $) of Taxes on goods and services in 2011?
Make the answer very short. 7.42e+1. What is the difference between the Taxes (in $) in Taxes on revenue in 2010 and the Taxes (in $) in Taxes on income in 2011?
Ensure brevity in your answer.  1.77e+11. What is the difference between the Taxes (in $) of Taxes on exports in 2010 and the Taxes (in $) of Taxes on goods and services in 2011?
Keep it short and to the point. -1.68e+11. What is the difference between the Taxes (in $) of Taxes on exports in 2010 and the Taxes (in $) of Taxes on income in 2011?
Provide a short and direct response. -6.51e+1. What is the difference between the Taxes (in $) in Taxes on goods and services in 2010 and the Taxes (in $) in Taxes on income in 2011?
Offer a very short reply. 8.66e+1. What is the average Taxes (in $) of Taxes on revenue per year?
Provide a short and direct response. 2.03e+11. What is the average Taxes (in $) of Taxes on exports per year?
Give a very brief answer. 3.07e+08. What is the average Taxes (in $) in Taxes on goods and services per year?
Offer a terse response. 1.19e+11. What is the average Taxes (in $) of Taxes on income per year?
Give a very brief answer. 4.75e+1. In the year 2004, what is the difference between the Taxes (in $) in Taxes on revenue and Taxes (in $) in Taxes on exports?
Give a very brief answer. 1.15e+11. In the year 2004, what is the difference between the Taxes (in $) in Taxes on revenue and Taxes (in $) in Taxes on goods and services?
Provide a short and direct response. 6.37e+1. In the year 2004, what is the difference between the Taxes (in $) of Taxes on revenue and Taxes (in $) of Taxes on income?
Your answer should be very brief. 9.28e+1. In the year 2004, what is the difference between the Taxes (in $) of Taxes on exports and Taxes (in $) of Taxes on goods and services?
Provide a succinct answer. -5.18e+1. In the year 2004, what is the difference between the Taxes (in $) in Taxes on exports and Taxes (in $) in Taxes on income?
Offer a terse response. -2.27e+1. In the year 2004, what is the difference between the Taxes (in $) in Taxes on goods and services and Taxes (in $) in Taxes on income?
Provide a short and direct response. 2.91e+1. In the year 2005, what is the difference between the Taxes (in $) in Taxes on revenue and Taxes (in $) in Taxes on exports?
Make the answer very short. 1.48e+11. In the year 2005, what is the difference between the Taxes (in $) of Taxes on revenue and Taxes (in $) of Taxes on goods and services?
Your response must be concise. 7.13e+1. In the year 2005, what is the difference between the Taxes (in $) in Taxes on revenue and Taxes (in $) in Taxes on income?
Ensure brevity in your answer.  1.19e+11. In the year 2005, what is the difference between the Taxes (in $) of Taxes on exports and Taxes (in $) of Taxes on goods and services?
Your answer should be very brief. -7.71e+1. In the year 2005, what is the difference between the Taxes (in $) of Taxes on exports and Taxes (in $) of Taxes on income?
Ensure brevity in your answer.  -2.96e+1. In the year 2005, what is the difference between the Taxes (in $) of Taxes on goods and services and Taxes (in $) of Taxes on income?
Your answer should be compact. 4.76e+1. In the year 2006, what is the difference between the Taxes (in $) of Taxes on revenue and Taxes (in $) of Taxes on exports?
Your answer should be very brief. 1.76e+11. In the year 2006, what is the difference between the Taxes (in $) in Taxes on revenue and Taxes (in $) in Taxes on goods and services?
Make the answer very short. 7.30e+1. In the year 2006, what is the difference between the Taxes (in $) in Taxes on revenue and Taxes (in $) in Taxes on income?
Your answer should be very brief. 1.38e+11. In the year 2006, what is the difference between the Taxes (in $) in Taxes on exports and Taxes (in $) in Taxes on goods and services?
Make the answer very short. -1.03e+11. In the year 2006, what is the difference between the Taxes (in $) of Taxes on exports and Taxes (in $) of Taxes on income?
Provide a succinct answer. -3.89e+1. In the year 2006, what is the difference between the Taxes (in $) of Taxes on goods and services and Taxes (in $) of Taxes on income?
Ensure brevity in your answer.  6.45e+1. In the year 2007, what is the difference between the Taxes (in $) in Taxes on revenue and Taxes (in $) in Taxes on exports?
Give a very brief answer. 2.17e+11. In the year 2007, what is the difference between the Taxes (in $) in Taxes on revenue and Taxes (in $) in Taxes on goods and services?
Make the answer very short. 8.89e+1. In the year 2007, what is the difference between the Taxes (in $) in Taxes on revenue and Taxes (in $) in Taxes on income?
Provide a short and direct response. 1.62e+11. In the year 2007, what is the difference between the Taxes (in $) of Taxes on exports and Taxes (in $) of Taxes on goods and services?
Offer a terse response. -1.28e+11. In the year 2007, what is the difference between the Taxes (in $) of Taxes on exports and Taxes (in $) of Taxes on income?
Make the answer very short. -5.51e+1. In the year 2007, what is the difference between the Taxes (in $) of Taxes on goods and services and Taxes (in $) of Taxes on income?
Ensure brevity in your answer.  7.30e+1. In the year 2008, what is the difference between the Taxes (in $) of Taxes on revenue and Taxes (in $) of Taxes on exports?
Offer a very short reply. 2.35e+11. In the year 2008, what is the difference between the Taxes (in $) of Taxes on revenue and Taxes (in $) of Taxes on goods and services?
Make the answer very short. 9.55e+1. In the year 2008, what is the difference between the Taxes (in $) in Taxes on revenue and Taxes (in $) in Taxes on income?
Offer a very short reply. 1.77e+11. In the year 2008, what is the difference between the Taxes (in $) in Taxes on exports and Taxes (in $) in Taxes on goods and services?
Make the answer very short. -1.40e+11. In the year 2008, what is the difference between the Taxes (in $) in Taxes on exports and Taxes (in $) in Taxes on income?
Offer a very short reply. -5.84e+1. In the year 2008, what is the difference between the Taxes (in $) in Taxes on goods and services and Taxes (in $) in Taxes on income?
Offer a terse response. 8.12e+1. In the year 2009, what is the difference between the Taxes (in $) in Taxes on revenue and Taxes (in $) in Taxes on exports?
Your response must be concise. 2.19e+11. In the year 2009, what is the difference between the Taxes (in $) of Taxes on revenue and Taxes (in $) of Taxes on goods and services?
Offer a terse response. 8.70e+1. In the year 2009, what is the difference between the Taxes (in $) of Taxes on revenue and Taxes (in $) of Taxes on income?
Offer a terse response. 1.65e+11. In the year 2009, what is the difference between the Taxes (in $) of Taxes on exports and Taxes (in $) of Taxes on goods and services?
Offer a very short reply. -1.32e+11. In the year 2009, what is the difference between the Taxes (in $) in Taxes on exports and Taxes (in $) in Taxes on income?
Make the answer very short. -5.40e+1. In the year 2009, what is the difference between the Taxes (in $) of Taxes on goods and services and Taxes (in $) of Taxes on income?
Offer a terse response. 7.83e+1. In the year 2010, what is the difference between the Taxes (in $) of Taxes on revenue and Taxes (in $) of Taxes on exports?
Your response must be concise. 2.42e+11. In the year 2010, what is the difference between the Taxes (in $) in Taxes on revenue and Taxes (in $) in Taxes on goods and services?
Offer a very short reply. 9.03e+1. In the year 2010, what is the difference between the Taxes (in $) of Taxes on revenue and Taxes (in $) of Taxes on income?
Your answer should be very brief. 1.88e+11. In the year 2010, what is the difference between the Taxes (in $) in Taxes on exports and Taxes (in $) in Taxes on goods and services?
Your answer should be compact. -1.52e+11. In the year 2010, what is the difference between the Taxes (in $) in Taxes on exports and Taxes (in $) in Taxes on income?
Your response must be concise. -5.35e+1. In the year 2010, what is the difference between the Taxes (in $) of Taxes on goods and services and Taxes (in $) of Taxes on income?
Provide a succinct answer. 9.82e+1. In the year 2011, what is the difference between the Taxes (in $) in Taxes on revenue and Taxes (in $) in Taxes on exports?
Give a very brief answer. 2.72e+11. In the year 2011, what is the difference between the Taxes (in $) of Taxes on revenue and Taxes (in $) of Taxes on goods and services?
Your answer should be very brief. 1.04e+11. In the year 2011, what is the difference between the Taxes (in $) in Taxes on revenue and Taxes (in $) in Taxes on income?
Your response must be concise. 2.07e+11. In the year 2011, what is the difference between the Taxes (in $) of Taxes on exports and Taxes (in $) of Taxes on goods and services?
Offer a very short reply. -1.68e+11. In the year 2011, what is the difference between the Taxes (in $) of Taxes on exports and Taxes (in $) of Taxes on income?
Keep it short and to the point. -6.50e+1. In the year 2011, what is the difference between the Taxes (in $) of Taxes on goods and services and Taxes (in $) of Taxes on income?
Your answer should be very brief. 1.03e+11. What is the ratio of the Taxes (in $) of Taxes on revenue in 2004 to that in 2005?
Your answer should be compact. 0.79. What is the ratio of the Taxes (in $) of Taxes on exports in 2004 to that in 2005?
Your answer should be very brief. 125.75. What is the ratio of the Taxes (in $) in Taxes on goods and services in 2004 to that in 2005?
Give a very brief answer. 0.69. What is the ratio of the Taxes (in $) of Taxes on income in 2004 to that in 2005?
Provide a succinct answer. 0.82. What is the ratio of the Taxes (in $) of Taxes on revenue in 2004 to that in 2006?
Your response must be concise. 0.66. What is the ratio of the Taxes (in $) in Taxes on exports in 2004 to that in 2006?
Offer a terse response. 24.73. What is the ratio of the Taxes (in $) of Taxes on goods and services in 2004 to that in 2006?
Give a very brief answer. 0.52. What is the ratio of the Taxes (in $) in Taxes on income in 2004 to that in 2006?
Provide a succinct answer. 0.63. What is the ratio of the Taxes (in $) in Taxes on revenue in 2004 to that in 2007?
Ensure brevity in your answer.  0.54. What is the ratio of the Taxes (in $) of Taxes on exports in 2004 to that in 2007?
Your response must be concise. 20.68. What is the ratio of the Taxes (in $) of Taxes on goods and services in 2004 to that in 2007?
Offer a very short reply. 0.42. What is the ratio of the Taxes (in $) of Taxes on income in 2004 to that in 2007?
Your answer should be very brief. 0.44. What is the ratio of the Taxes (in $) of Taxes on revenue in 2004 to that in 2008?
Give a very brief answer. 0.5. What is the ratio of the Taxes (in $) in Taxes on exports in 2004 to that in 2008?
Ensure brevity in your answer.  13.31. What is the ratio of the Taxes (in $) of Taxes on goods and services in 2004 to that in 2008?
Give a very brief answer. 0.38. What is the ratio of the Taxes (in $) of Taxes on income in 2004 to that in 2008?
Make the answer very short. 0.42. What is the ratio of the Taxes (in $) in Taxes on revenue in 2004 to that in 2009?
Give a very brief answer. 0.53. What is the ratio of the Taxes (in $) in Taxes on exports in 2004 to that in 2009?
Provide a succinct answer. 12.96. What is the ratio of the Taxes (in $) of Taxes on goods and services in 2004 to that in 2009?
Ensure brevity in your answer.  0.4. What is the ratio of the Taxes (in $) of Taxes on income in 2004 to that in 2009?
Provide a short and direct response. 0.45. What is the ratio of the Taxes (in $) in Taxes on revenue in 2004 to that in 2010?
Keep it short and to the point. 0.48. What is the ratio of the Taxes (in $) of Taxes on exports in 2004 to that in 2010?
Make the answer very short. 11.66. What is the ratio of the Taxes (in $) in Taxes on goods and services in 2004 to that in 2010?
Provide a succinct answer. 0.35. What is the ratio of the Taxes (in $) of Taxes on income in 2004 to that in 2010?
Make the answer very short. 0.45. What is the ratio of the Taxes (in $) of Taxes on revenue in 2004 to that in 2011?
Provide a succinct answer. 0.43. What is the ratio of the Taxes (in $) in Taxes on exports in 2004 to that in 2011?
Your response must be concise. 9.41. What is the ratio of the Taxes (in $) of Taxes on goods and services in 2004 to that in 2011?
Keep it short and to the point. 0.32. What is the ratio of the Taxes (in $) of Taxes on income in 2004 to that in 2011?
Give a very brief answer. 0.37. What is the ratio of the Taxes (in $) of Taxes on revenue in 2005 to that in 2006?
Your response must be concise. 0.84. What is the ratio of the Taxes (in $) of Taxes on exports in 2005 to that in 2006?
Keep it short and to the point. 0.2. What is the ratio of the Taxes (in $) in Taxes on goods and services in 2005 to that in 2006?
Offer a very short reply. 0.75. What is the ratio of the Taxes (in $) in Taxes on income in 2005 to that in 2006?
Provide a succinct answer. 0.76. What is the ratio of the Taxes (in $) in Taxes on revenue in 2005 to that in 2007?
Your answer should be compact. 0.68. What is the ratio of the Taxes (in $) of Taxes on exports in 2005 to that in 2007?
Your answer should be compact. 0.16. What is the ratio of the Taxes (in $) in Taxes on goods and services in 2005 to that in 2007?
Provide a succinct answer. 0.6. What is the ratio of the Taxes (in $) in Taxes on income in 2005 to that in 2007?
Provide a succinct answer. 0.54. What is the ratio of the Taxes (in $) in Taxes on revenue in 2005 to that in 2008?
Your response must be concise. 0.63. What is the ratio of the Taxes (in $) in Taxes on exports in 2005 to that in 2008?
Your answer should be very brief. 0.11. What is the ratio of the Taxes (in $) of Taxes on goods and services in 2005 to that in 2008?
Your answer should be compact. 0.55. What is the ratio of the Taxes (in $) of Taxes on income in 2005 to that in 2008?
Ensure brevity in your answer.  0.51. What is the ratio of the Taxes (in $) of Taxes on revenue in 2005 to that in 2009?
Make the answer very short. 0.68. What is the ratio of the Taxes (in $) in Taxes on exports in 2005 to that in 2009?
Provide a succinct answer. 0.1. What is the ratio of the Taxes (in $) in Taxes on goods and services in 2005 to that in 2009?
Provide a succinct answer. 0.58. What is the ratio of the Taxes (in $) in Taxes on income in 2005 to that in 2009?
Offer a terse response. 0.55. What is the ratio of the Taxes (in $) in Taxes on revenue in 2005 to that in 2010?
Offer a terse response. 0.61. What is the ratio of the Taxes (in $) of Taxes on exports in 2005 to that in 2010?
Your answer should be compact. 0.09. What is the ratio of the Taxes (in $) of Taxes on goods and services in 2005 to that in 2010?
Provide a succinct answer. 0.51. What is the ratio of the Taxes (in $) of Taxes on income in 2005 to that in 2010?
Make the answer very short. 0.55. What is the ratio of the Taxes (in $) of Taxes on revenue in 2005 to that in 2011?
Offer a terse response. 0.55. What is the ratio of the Taxes (in $) in Taxes on exports in 2005 to that in 2011?
Ensure brevity in your answer.  0.07. What is the ratio of the Taxes (in $) in Taxes on goods and services in 2005 to that in 2011?
Give a very brief answer. 0.46. What is the ratio of the Taxes (in $) in Taxes on income in 2005 to that in 2011?
Keep it short and to the point. 0.45. What is the ratio of the Taxes (in $) in Taxes on revenue in 2006 to that in 2007?
Your answer should be compact. 0.81. What is the ratio of the Taxes (in $) of Taxes on exports in 2006 to that in 2007?
Offer a very short reply. 0.84. What is the ratio of the Taxes (in $) of Taxes on goods and services in 2006 to that in 2007?
Your answer should be very brief. 0.81. What is the ratio of the Taxes (in $) in Taxes on income in 2006 to that in 2007?
Provide a succinct answer. 0.71. What is the ratio of the Taxes (in $) in Taxes on revenue in 2006 to that in 2008?
Ensure brevity in your answer.  0.75. What is the ratio of the Taxes (in $) of Taxes on exports in 2006 to that in 2008?
Give a very brief answer. 0.54. What is the ratio of the Taxes (in $) of Taxes on goods and services in 2006 to that in 2008?
Give a very brief answer. 0.74. What is the ratio of the Taxes (in $) of Taxes on income in 2006 to that in 2008?
Ensure brevity in your answer.  0.67. What is the ratio of the Taxes (in $) of Taxes on revenue in 2006 to that in 2009?
Provide a succinct answer. 0.8. What is the ratio of the Taxes (in $) of Taxes on exports in 2006 to that in 2009?
Provide a succinct answer. 0.52. What is the ratio of the Taxes (in $) in Taxes on goods and services in 2006 to that in 2009?
Offer a very short reply. 0.78. What is the ratio of the Taxes (in $) of Taxes on income in 2006 to that in 2009?
Your answer should be very brief. 0.72. What is the ratio of the Taxes (in $) of Taxes on revenue in 2006 to that in 2010?
Offer a very short reply. 0.73. What is the ratio of the Taxes (in $) of Taxes on exports in 2006 to that in 2010?
Your response must be concise. 0.47. What is the ratio of the Taxes (in $) of Taxes on goods and services in 2006 to that in 2010?
Keep it short and to the point. 0.68. What is the ratio of the Taxes (in $) in Taxes on income in 2006 to that in 2010?
Ensure brevity in your answer.  0.73. What is the ratio of the Taxes (in $) in Taxes on revenue in 2006 to that in 2011?
Give a very brief answer. 0.65. What is the ratio of the Taxes (in $) in Taxes on exports in 2006 to that in 2011?
Your answer should be very brief. 0.38. What is the ratio of the Taxes (in $) in Taxes on goods and services in 2006 to that in 2011?
Your answer should be compact. 0.62. What is the ratio of the Taxes (in $) of Taxes on income in 2006 to that in 2011?
Provide a short and direct response. 0.6. What is the ratio of the Taxes (in $) of Taxes on revenue in 2007 to that in 2008?
Your answer should be very brief. 0.92. What is the ratio of the Taxes (in $) in Taxes on exports in 2007 to that in 2008?
Your response must be concise. 0.64. What is the ratio of the Taxes (in $) in Taxes on goods and services in 2007 to that in 2008?
Make the answer very short. 0.92. What is the ratio of the Taxes (in $) in Taxes on income in 2007 to that in 2008?
Your answer should be very brief. 0.94. What is the ratio of the Taxes (in $) of Taxes on exports in 2007 to that in 2009?
Your answer should be compact. 0.63. What is the ratio of the Taxes (in $) in Taxes on goods and services in 2007 to that in 2009?
Keep it short and to the point. 0.97. What is the ratio of the Taxes (in $) of Taxes on income in 2007 to that in 2009?
Make the answer very short. 1.02. What is the ratio of the Taxes (in $) in Taxes on revenue in 2007 to that in 2010?
Provide a short and direct response. 0.9. What is the ratio of the Taxes (in $) in Taxes on exports in 2007 to that in 2010?
Make the answer very short. 0.56. What is the ratio of the Taxes (in $) of Taxes on goods and services in 2007 to that in 2010?
Your answer should be compact. 0.84. What is the ratio of the Taxes (in $) of Taxes on income in 2007 to that in 2010?
Make the answer very short. 1.03. What is the ratio of the Taxes (in $) of Taxes on revenue in 2007 to that in 2011?
Your answer should be very brief. 0.8. What is the ratio of the Taxes (in $) of Taxes on exports in 2007 to that in 2011?
Your response must be concise. 0.46. What is the ratio of the Taxes (in $) in Taxes on goods and services in 2007 to that in 2011?
Ensure brevity in your answer.  0.76. What is the ratio of the Taxes (in $) in Taxes on income in 2007 to that in 2011?
Your response must be concise. 0.85. What is the ratio of the Taxes (in $) of Taxes on revenue in 2008 to that in 2009?
Offer a terse response. 1.07. What is the ratio of the Taxes (in $) in Taxes on exports in 2008 to that in 2009?
Provide a succinct answer. 0.97. What is the ratio of the Taxes (in $) of Taxes on goods and services in 2008 to that in 2009?
Provide a succinct answer. 1.06. What is the ratio of the Taxes (in $) in Taxes on income in 2008 to that in 2009?
Offer a terse response. 1.08. What is the ratio of the Taxes (in $) in Taxes on revenue in 2008 to that in 2010?
Your answer should be compact. 0.97. What is the ratio of the Taxes (in $) in Taxes on exports in 2008 to that in 2010?
Your answer should be very brief. 0.88. What is the ratio of the Taxes (in $) in Taxes on goods and services in 2008 to that in 2010?
Give a very brief answer. 0.92. What is the ratio of the Taxes (in $) in Taxes on income in 2008 to that in 2010?
Provide a short and direct response. 1.09. What is the ratio of the Taxes (in $) in Taxes on revenue in 2008 to that in 2011?
Provide a succinct answer. 0.87. What is the ratio of the Taxes (in $) of Taxes on exports in 2008 to that in 2011?
Make the answer very short. 0.71. What is the ratio of the Taxes (in $) in Taxes on goods and services in 2008 to that in 2011?
Provide a succinct answer. 0.83. What is the ratio of the Taxes (in $) in Taxes on income in 2008 to that in 2011?
Give a very brief answer. 0.9. What is the ratio of the Taxes (in $) of Taxes on revenue in 2009 to that in 2010?
Your answer should be very brief. 0.91. What is the ratio of the Taxes (in $) of Taxes on exports in 2009 to that in 2010?
Your answer should be compact. 0.9. What is the ratio of the Taxes (in $) in Taxes on goods and services in 2009 to that in 2010?
Offer a very short reply. 0.87. What is the ratio of the Taxes (in $) in Taxes on revenue in 2009 to that in 2011?
Keep it short and to the point. 0.81. What is the ratio of the Taxes (in $) of Taxes on exports in 2009 to that in 2011?
Keep it short and to the point. 0.73. What is the ratio of the Taxes (in $) in Taxes on goods and services in 2009 to that in 2011?
Provide a short and direct response. 0.79. What is the ratio of the Taxes (in $) in Taxes on income in 2009 to that in 2011?
Offer a very short reply. 0.83. What is the ratio of the Taxes (in $) of Taxes on revenue in 2010 to that in 2011?
Provide a succinct answer. 0.89. What is the ratio of the Taxes (in $) of Taxes on exports in 2010 to that in 2011?
Your answer should be compact. 0.81. What is the ratio of the Taxes (in $) in Taxes on goods and services in 2010 to that in 2011?
Your answer should be very brief. 0.9. What is the ratio of the Taxes (in $) of Taxes on income in 2010 to that in 2011?
Keep it short and to the point. 0.82. What is the difference between the highest and the second highest Taxes (in $) of Taxes on revenue?
Keep it short and to the point. 2.97e+1. What is the difference between the highest and the second highest Taxes (in $) of Taxes on exports?
Provide a short and direct response. 1.52e+09. What is the difference between the highest and the second highest Taxes (in $) of Taxes on goods and services?
Offer a very short reply. 1.61e+1. What is the difference between the highest and the second highest Taxes (in $) in Taxes on income?
Offer a very short reply. 6.67e+09. What is the difference between the highest and the lowest Taxes (in $) in Taxes on revenue?
Make the answer very short. 1.55e+11. What is the difference between the highest and the lowest Taxes (in $) in Taxes on exports?
Offer a terse response. 1.69e+09. What is the difference between the highest and the lowest Taxes (in $) of Taxes on goods and services?
Offer a very short reply. 1.14e+11. What is the difference between the highest and the lowest Taxes (in $) of Taxes on income?
Give a very brief answer. 4.08e+1. 